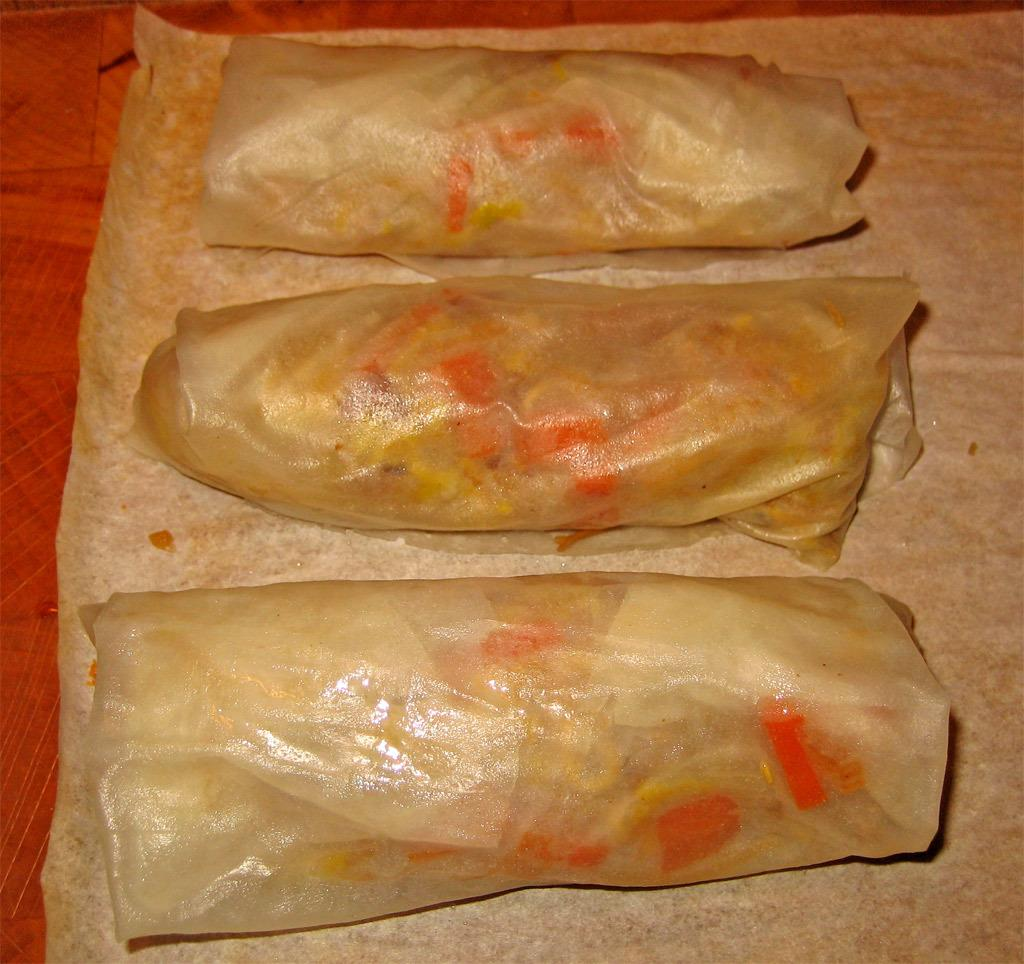What type of objects can be seen in the image? There are food items placed in the image. Can you describe the food items in the image? Unfortunately, the provided facts do not specify the type of food items present in the image. How many food items are visible in the image? The number of food items cannot be determined from the given facts. What day of the week is it in the image? The provided facts do not mention any information about the day of the week, so it cannot be determined from the image. 